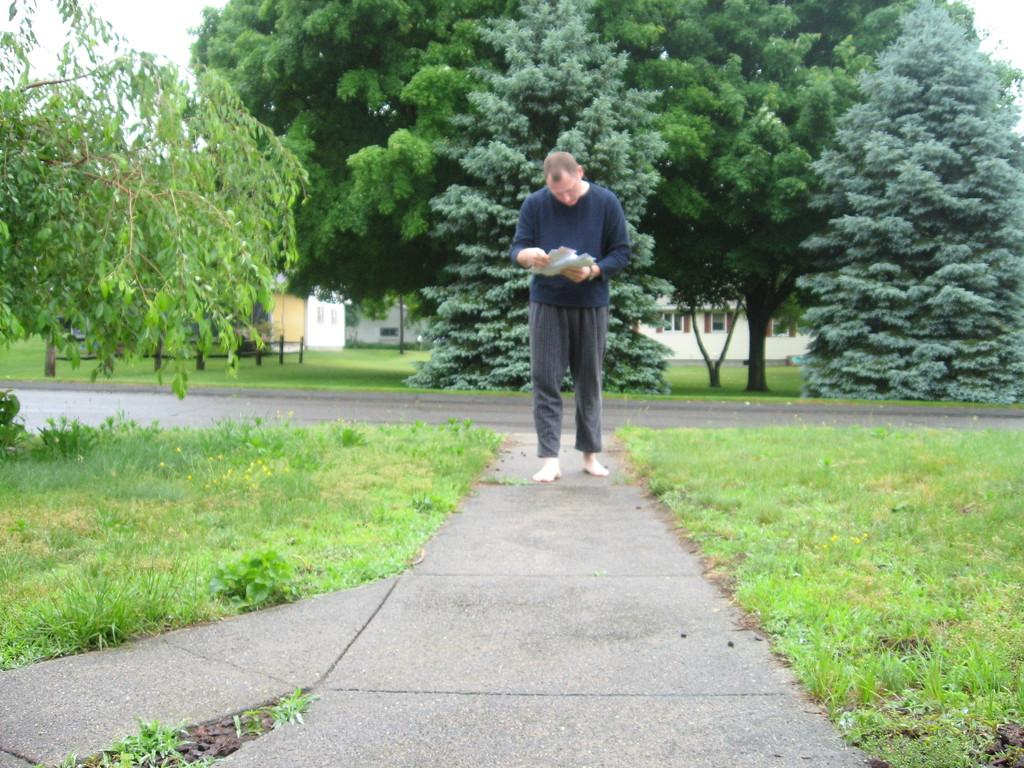What type of vegetation is present in the image? There is grass in the image. What is the person wearing in the image? The person is wearing a blue dress in the image. What objects can be seen in addition to the grass and person? There are papers in the image. What can be seen in the background of the image? There are trees and buildings in the background of the image. What is visible at the top of the image? The sky is visible at the top of the image. What type of pest can be seen crawling on the person's dress in the image? There is no pest visible on the person's dress in the image. What type of border is present around the grass in the image? There is no border present around the grass in the image. 